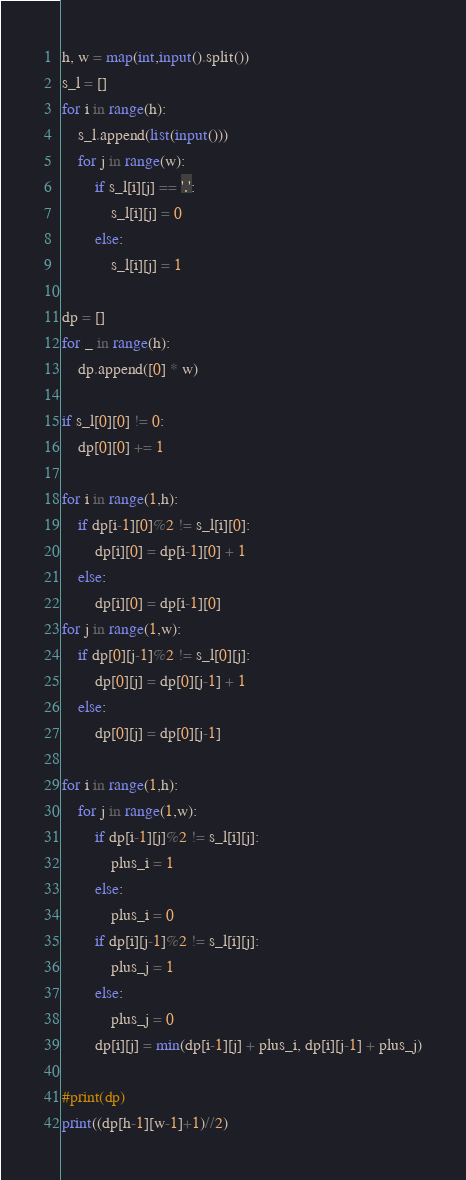<code> <loc_0><loc_0><loc_500><loc_500><_Python_>h, w = map(int,input().split())
s_l = []
for i in range(h):
    s_l.append(list(input()))
    for j in range(w):
        if s_l[i][j] == '.':
            s_l[i][j] = 0
        else:
            s_l[i][j] = 1

dp = []
for _ in range(h):
    dp.append([0] * w)

if s_l[0][0] != 0:
    dp[0][0] += 1

for i in range(1,h):
    if dp[i-1][0]%2 != s_l[i][0]:
        dp[i][0] = dp[i-1][0] + 1
    else:
        dp[i][0] = dp[i-1][0]
for j in range(1,w):
    if dp[0][j-1]%2 != s_l[0][j]:
        dp[0][j] = dp[0][j-1] + 1
    else:
        dp[0][j] = dp[0][j-1]

for i in range(1,h):
    for j in range(1,w):
        if dp[i-1][j]%2 != s_l[i][j]:
            plus_i = 1
        else:
            plus_i = 0
        if dp[i][j-1]%2 != s_l[i][j]:
            plus_j = 1
        else:
            plus_j = 0
        dp[i][j] = min(dp[i-1][j] + plus_i, dp[i][j-1] + plus_j)

#print(dp)
print((dp[h-1][w-1]+1)//2)</code> 